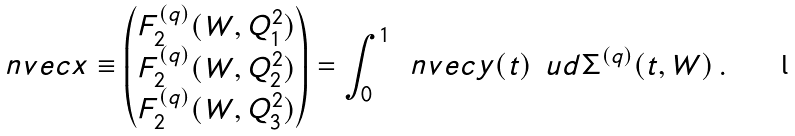<formula> <loc_0><loc_0><loc_500><loc_500>\ n v e c { x } \equiv \begin{pmatrix} F _ { 2 } ^ { ( q ) } ( W , Q _ { 1 } ^ { 2 } ) \\ F _ { 2 } ^ { ( q ) } ( W , Q _ { 2 } ^ { 2 } ) \\ F _ { 2 } ^ { ( q ) } ( W , Q _ { 3 } ^ { 2 } ) \end{pmatrix} = \int _ { 0 } ^ { 1 } \, \ n v e c { y } ( t ) \, \ u d { \Sigma ^ { ( q ) } ( t , W ) } \, .</formula> 